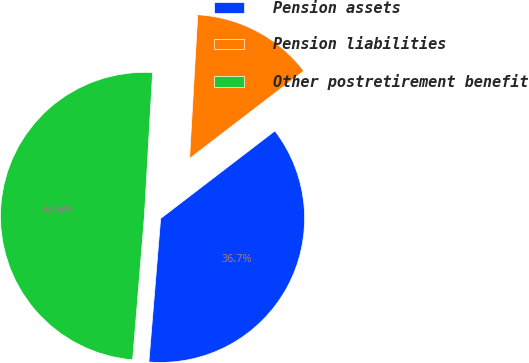Convert chart. <chart><loc_0><loc_0><loc_500><loc_500><pie_chart><fcel>Pension assets<fcel>Pension liabilities<fcel>Other postretirement benefit<nl><fcel>36.71%<fcel>13.69%<fcel>49.6%<nl></chart> 